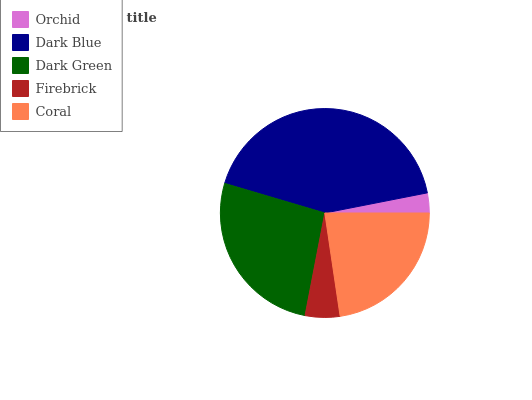Is Orchid the minimum?
Answer yes or no. Yes. Is Dark Blue the maximum?
Answer yes or no. Yes. Is Dark Green the minimum?
Answer yes or no. No. Is Dark Green the maximum?
Answer yes or no. No. Is Dark Blue greater than Dark Green?
Answer yes or no. Yes. Is Dark Green less than Dark Blue?
Answer yes or no. Yes. Is Dark Green greater than Dark Blue?
Answer yes or no. No. Is Dark Blue less than Dark Green?
Answer yes or no. No. Is Coral the high median?
Answer yes or no. Yes. Is Coral the low median?
Answer yes or no. Yes. Is Dark Blue the high median?
Answer yes or no. No. Is Orchid the low median?
Answer yes or no. No. 